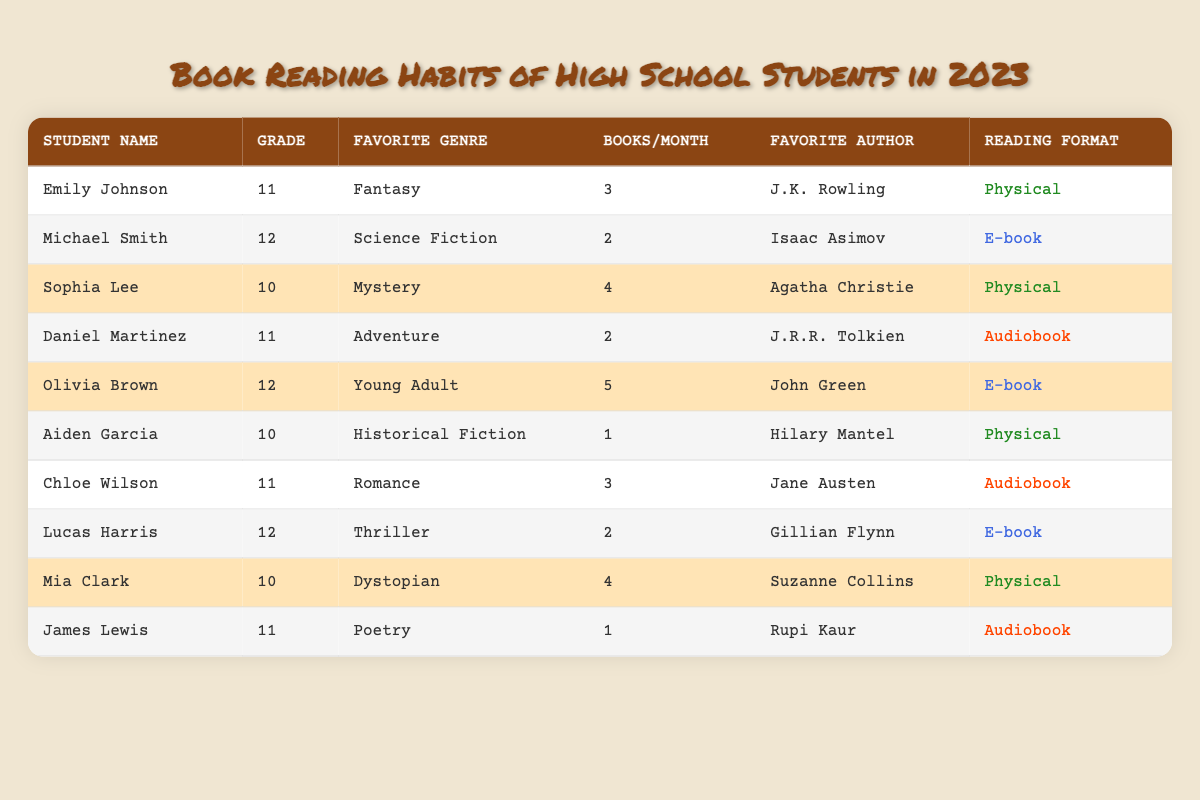What is the favorite genre of Olivia Brown? According to the table, Olivia Brown’s favorite genre is listed as "Young Adult."
Answer: Young Adult How many books does Emily Johnson read on average per month? The table indicates that Emily Johnson reads an average of 3 books per month.
Answer: 3 Which student has the highest average number of books read per month? By reviewing the table, Olivia Brown has the highest average at 5 books per month.
Answer: 5 Is Mia Clark's reading format physical or digital? The table shows that Mia Clark's reading format is "Physical."
Answer: Physical What genres do students in grade 12 prefer? Looking at the table, the favorite genres for grade 12 students Michael Smith, Olivia Brown, and Lucas Harris are Science Fiction, Young Adult, and Thriller, respectively.
Answer: Science Fiction, Young Adult, Thriller How many students read audiobooks? The table lists three students who have "Audiobook" as their reading format: Daniel Martinez, Chloe Wilson, and James Lewis.
Answer: 3 Calculate the average number of books read per month by all students in 10th grade. The students in 10th grade are Sophia Lee (4 books), Aiden Garcia (1 book), and Mia Clark (4 books). Adding these gives 4 + 1 + 4 = 9, and dividing by 3 gives an average of 9/3 = 3.
Answer: 3 Which favorite author is shared by any two students? Examining the table, there is no author listed that is shared by students; each student has a unique favorite author.
Answer: No Is the majority of students reading physical books? There are 5 students who prefer physical books out of 10 total students, so yes, the majority is physical.
Answer: Yes What is the difference in average books read per month between students in grades 11 and 12? The average for grade 11 students (Emily Johnson, Daniel Martinez, Chloe Wilson, and James Lewis) is (3 + 2 + 3 + 1)/4 = 2.25. The average for grade 12 students (Michael Smith, Olivia Brown, and Lucas Harris) is (2 + 5 + 2)/3 = 3. Thus, the difference is 3 - 2.25 = 0.75.
Answer: 0.75 